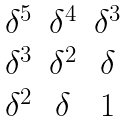<formula> <loc_0><loc_0><loc_500><loc_500>\begin{matrix} \delta ^ { 5 } & \delta ^ { 4 } & \delta ^ { 3 } \\ \delta ^ { 3 } & \delta ^ { 2 } & \delta \\ \delta ^ { 2 } & \delta & 1 \end{matrix}</formula> 